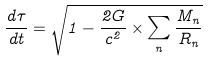<formula> <loc_0><loc_0><loc_500><loc_500>\frac { d \tau } { d t } = \sqrt { 1 - \frac { 2 G } { c ^ { 2 } } \times \sum _ { n } \frac { M _ { n } } { R _ { n } } }</formula> 